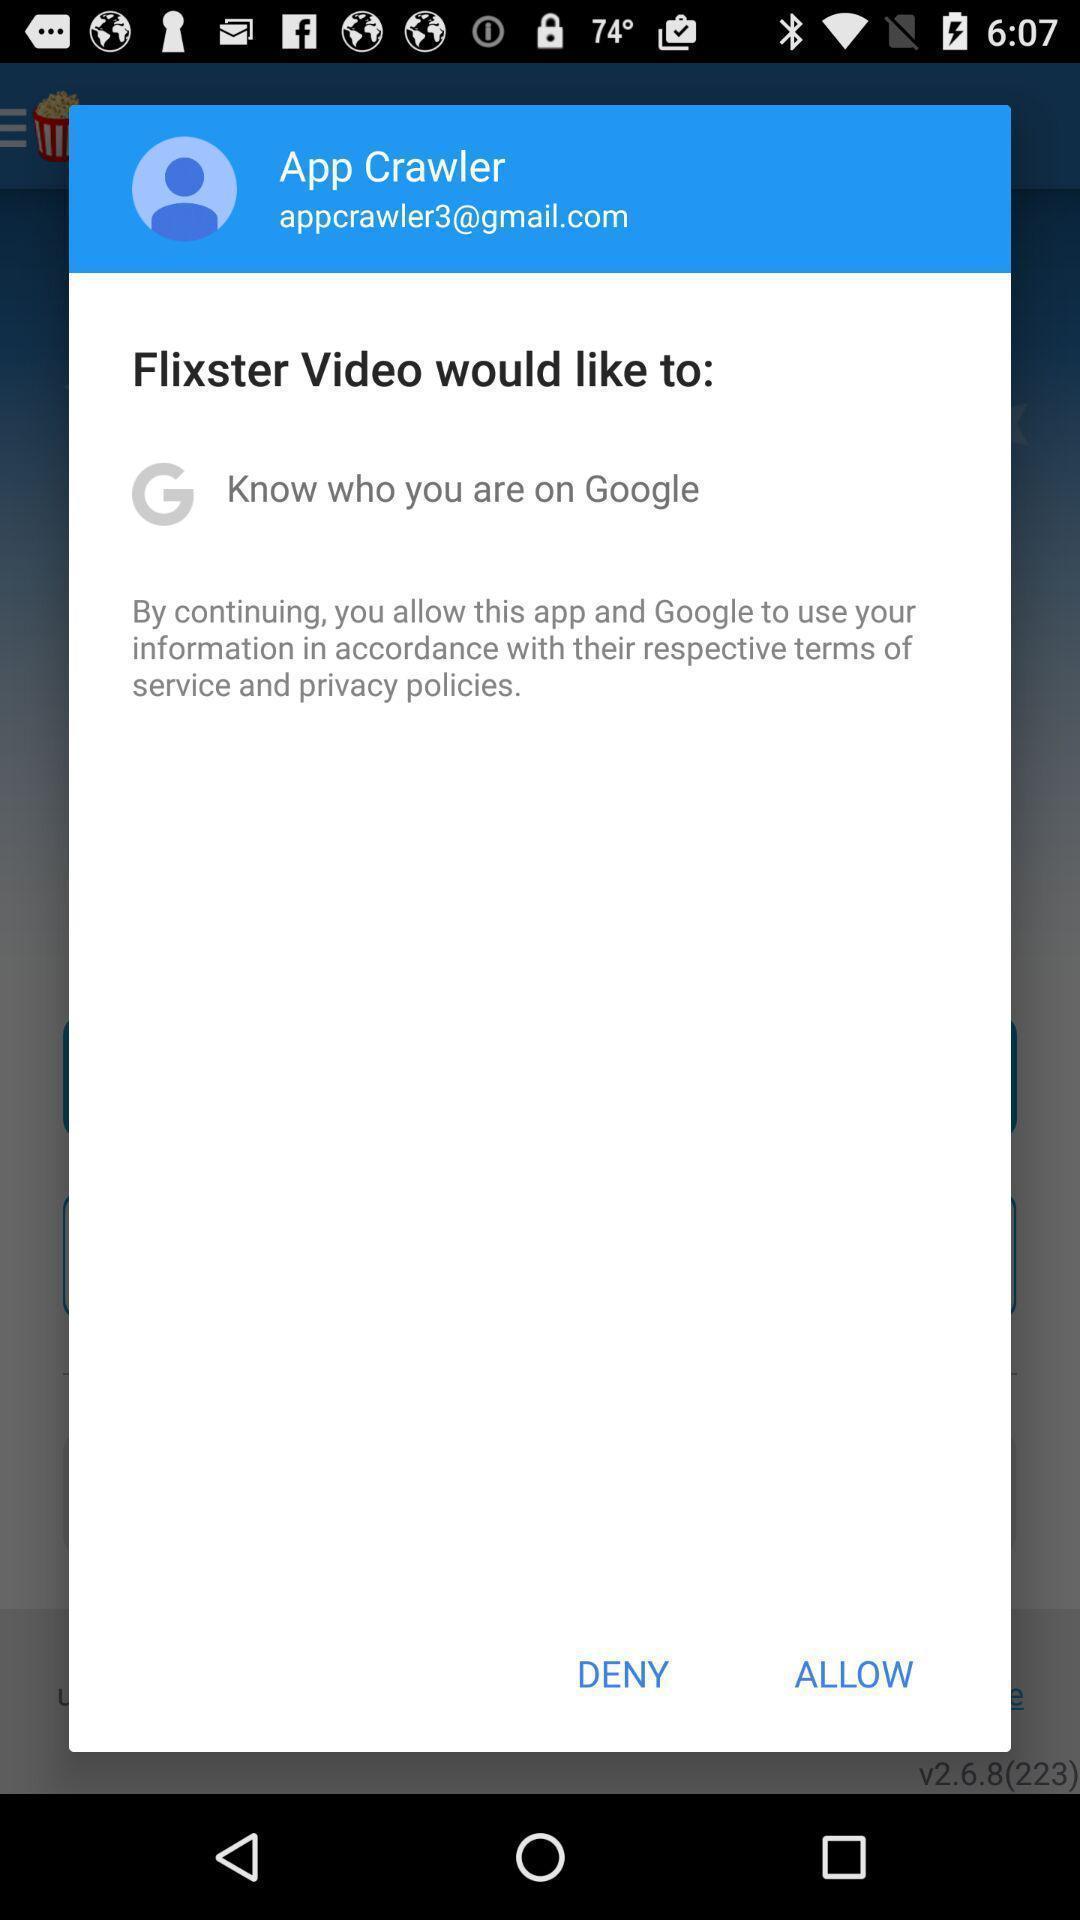Explain the elements present in this screenshot. Pop-up showing to allow or deny. 